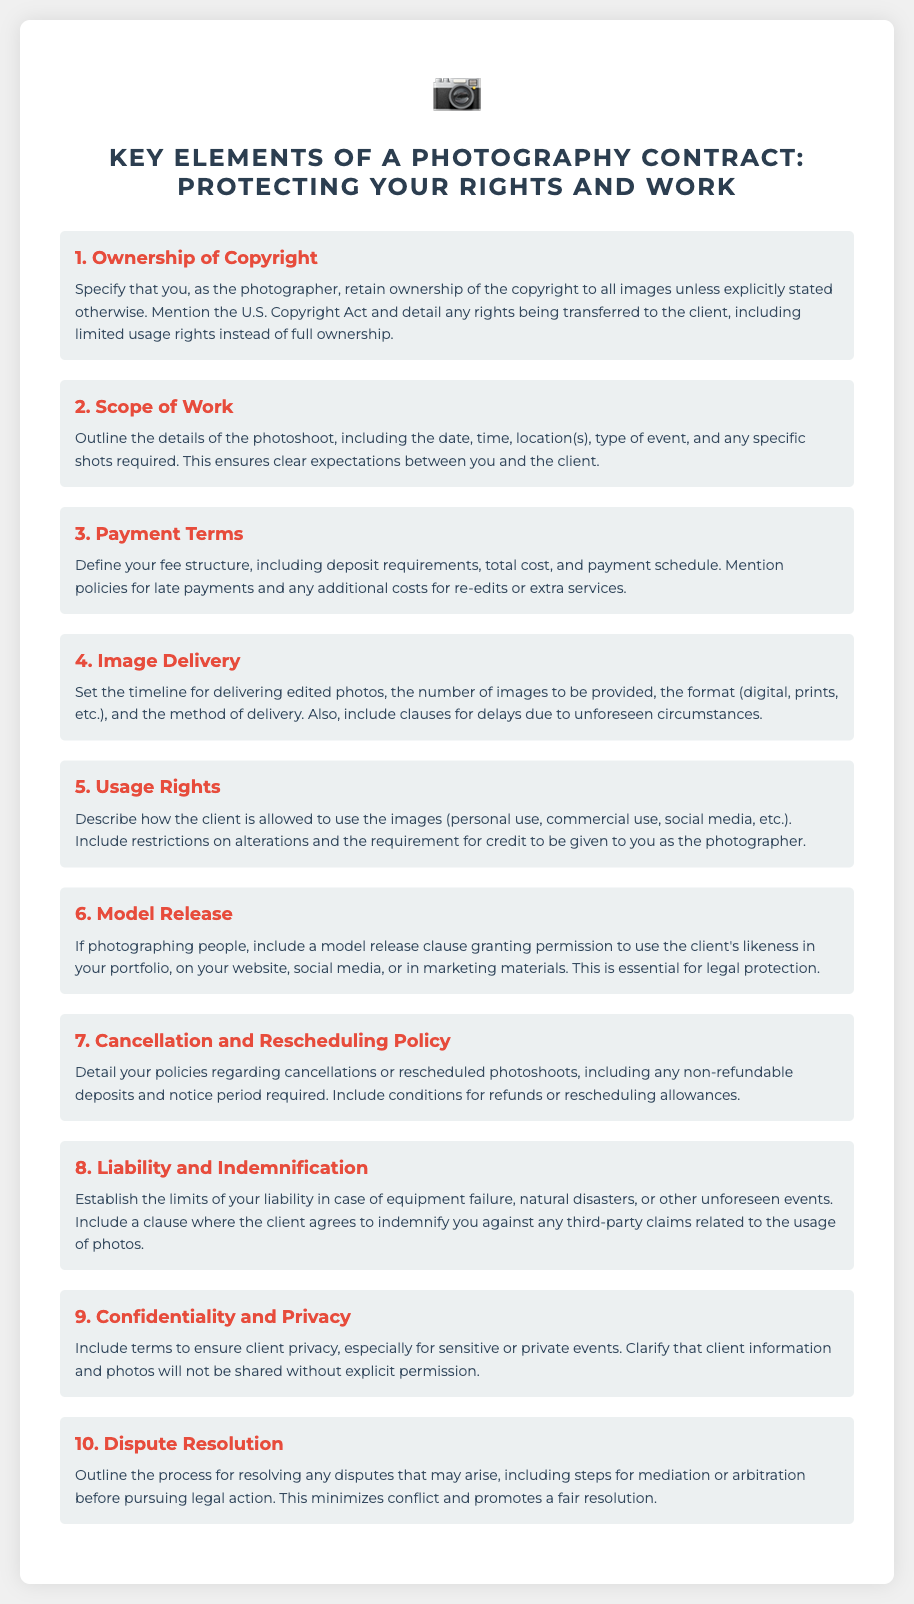What is the main title of the poster? The main title summarizes the key theme of the document, which is about photography contracts.
Answer: Key Elements of a Photography Contract: Protecting Your Rights and Work What section discusses payment terms? This section is important for understanding compensation agreements.
Answer: Payment Terms How many sections are there in the document? Counting the titles indicates the number of distinct topics covered.
Answer: 10 What does the model release clause pertain to? It is essential for legal protection when photographing individuals.
Answer: Permission to use Which section addresses client privacy? This is crucial for maintaining confidentiality in client dealings.
Answer: Confidentiality and Privacy What does the cancellation policy include? This section outlines the terms for changing or canceling a photoshoot.
Answer: Non-refundable deposits What are clients required to do regarding image usage? This ensures proper credit and legal acknowledgment of the photographer's work.
Answer: Requirement for credit What does the dispute resolution section aim to minimize? Understanding this helps in addressing potential conflicts effectively.
Answer: Conflict 